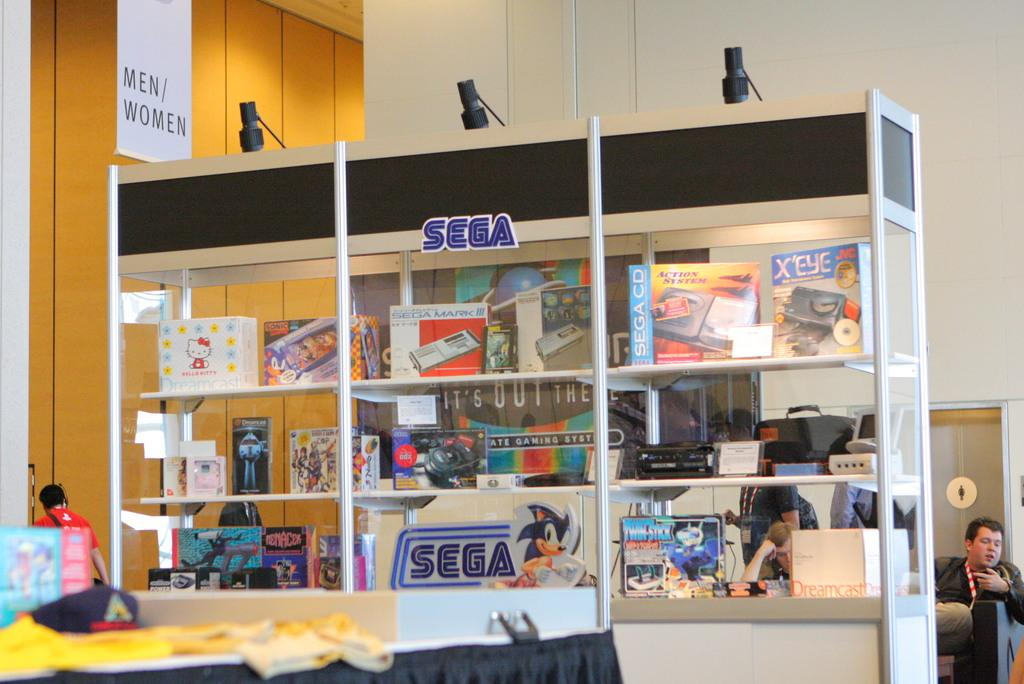Provide a one-sentence caption for the provided image. A glass display box proudnly displays many Sega items. 